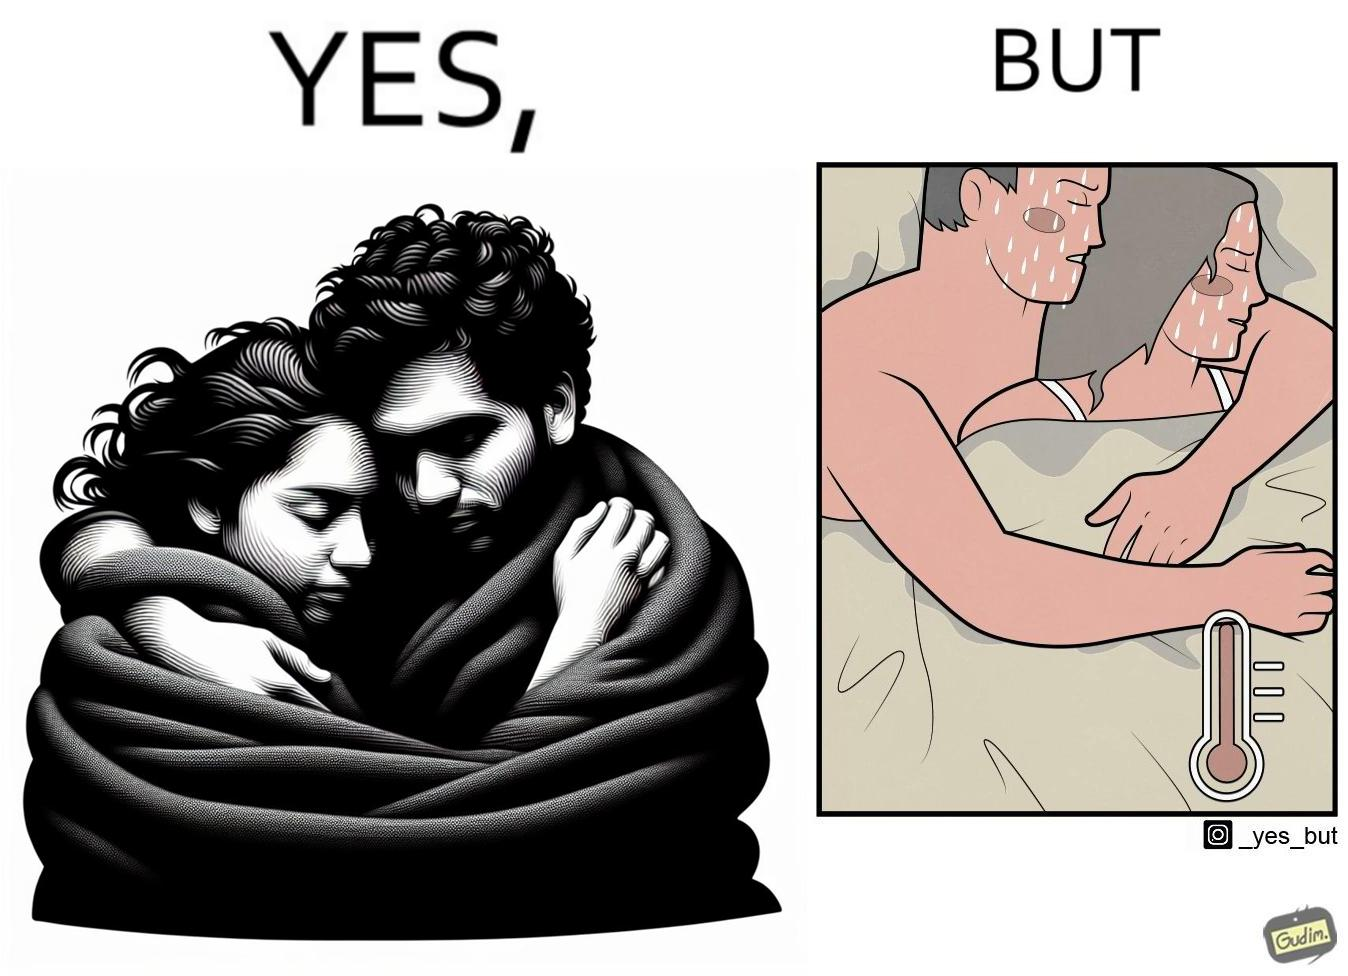What makes this image funny or satirical? The image is ironic, because after some time cuddling within a blanket raises the temperature which leads to inconvenience 